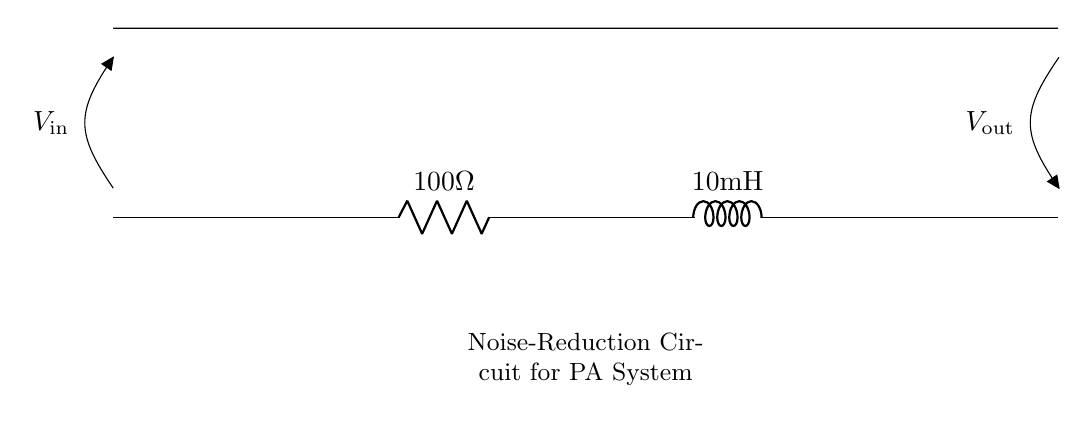What are the components in this circuit? The components illustrated in the circuit are a resistor and an inductor. Specifically, the resistor is labeled as one hundred ohms and the inductor is labeled as ten millihenries.
Answer: Resistor, Inductor What is the value of the resistor? The label on the resistor shows a value of one hundred ohms. This indicates the resistance it provides in the circuit.
Answer: 100 ohms What is the value of the inductor? The inductor is specified to have a value of ten millihenries, which is a measurement of its inductance.
Answer: 10 millihenries What is the purpose of this circuit? The circuit is designed for noise reduction in a public address system, evidenced by the text indicating its function below the circuit.
Answer: Noise-reduction What is the input voltage type in this circuit? The voltage is noted as V-in, indicating that it is the input voltage; however, the specific type of voltage is not detailed in the provided information.
Answer: V-in How does the inductor affect the circuit? The inductor opposes changes in current flow and provides filtering, which is essential for reducing noise in audio signals, therefore enhancing sound clarity in the public address system.
Answer: Filters noise What is V-out in the context of this circuit? V-out represents the output voltage across the load or output terminals, indicating the voltage that is available after the noise reduction has been applied by the circuit.
Answer: V-out 